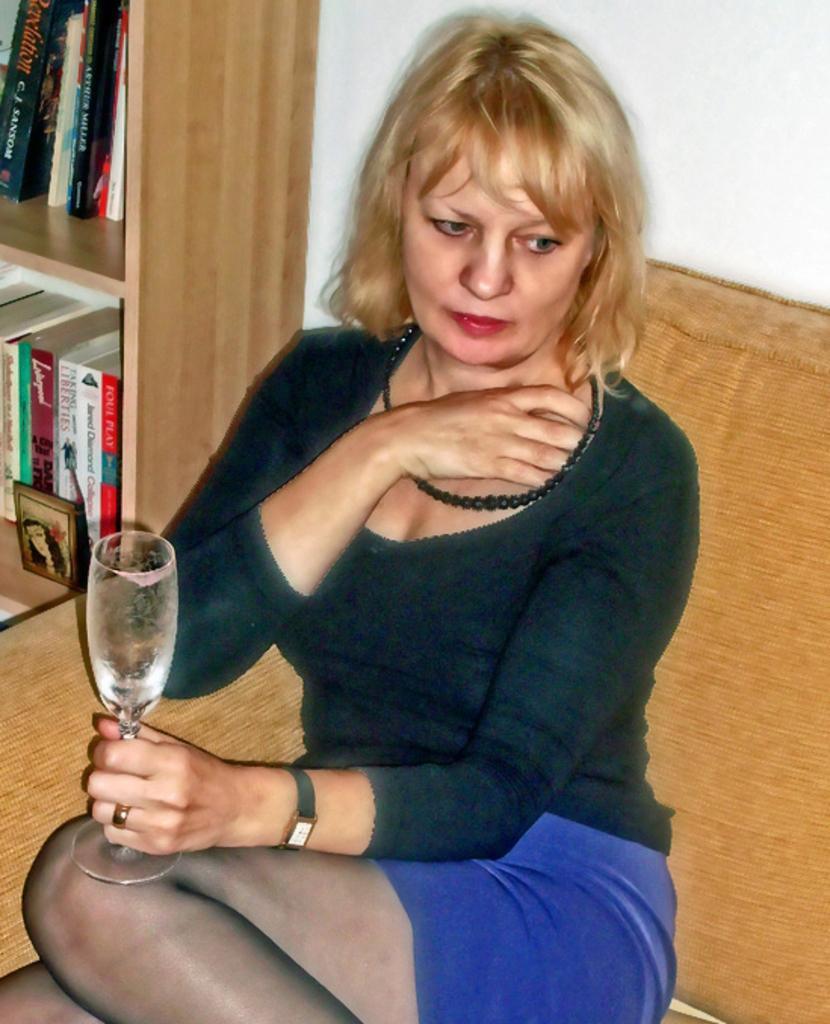In one or two sentences, can you explain what this image depicts? In this image we can see a lady sitting on a couch. A lady is holding a drink glass. There are many books placed in a wood rack. 